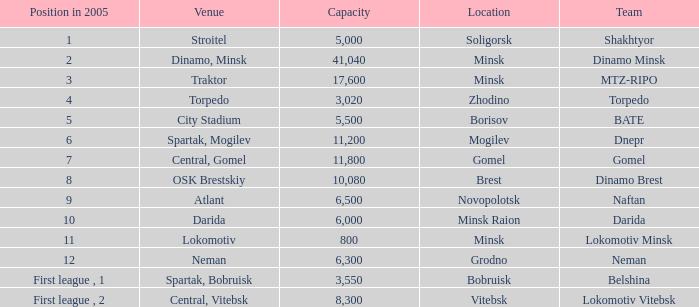Can you tell me the highest Capacity that has the Team of torpedo? 3020.0. 